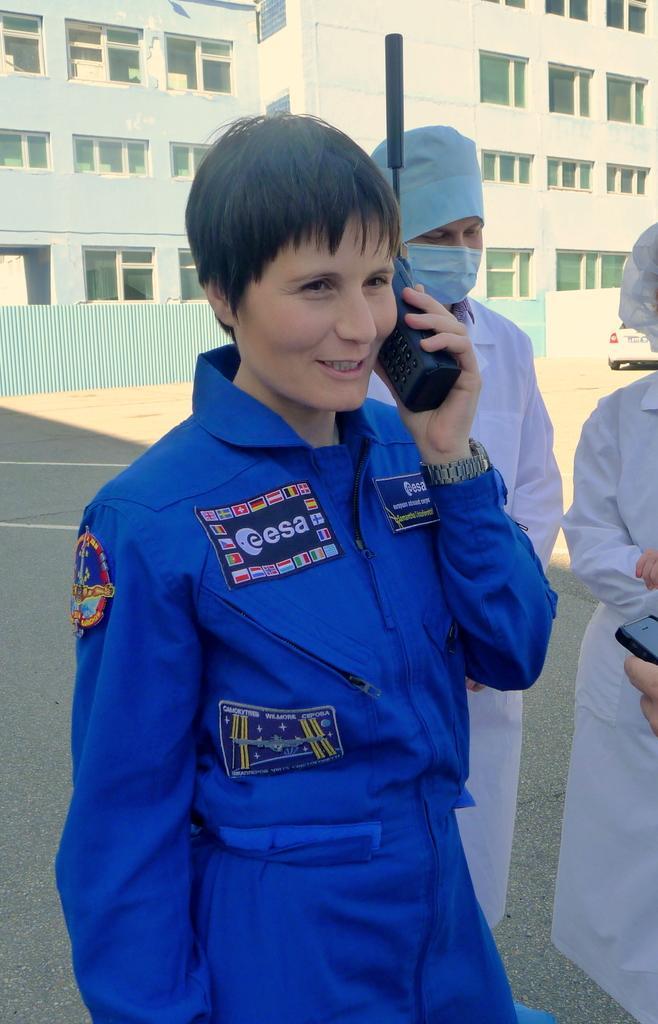Could you give a brief overview of what you see in this image? In this image we can see a woman wearing a blue dress and holding a mobile in her hand. In the background, we can see two persons wearing white dress and a vehicle parked on the ground, a building with a group of windows on it. 